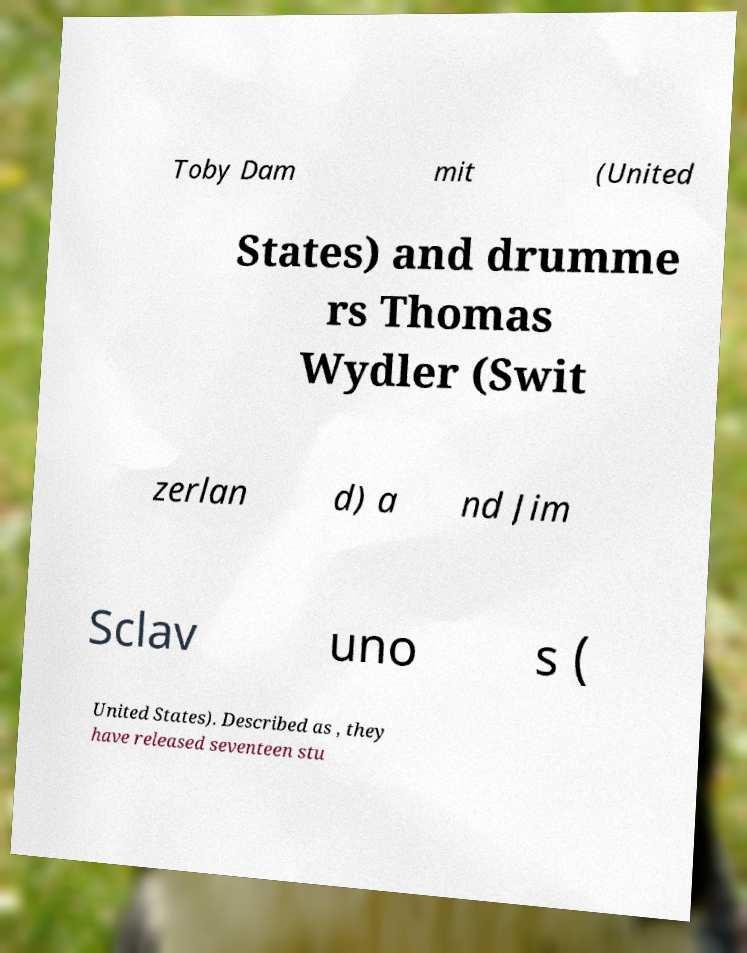What messages or text are displayed in this image? I need them in a readable, typed format. Toby Dam mit (United States) and drumme rs Thomas Wydler (Swit zerlan d) a nd Jim Sclav uno s ( United States). Described as , they have released seventeen stu 